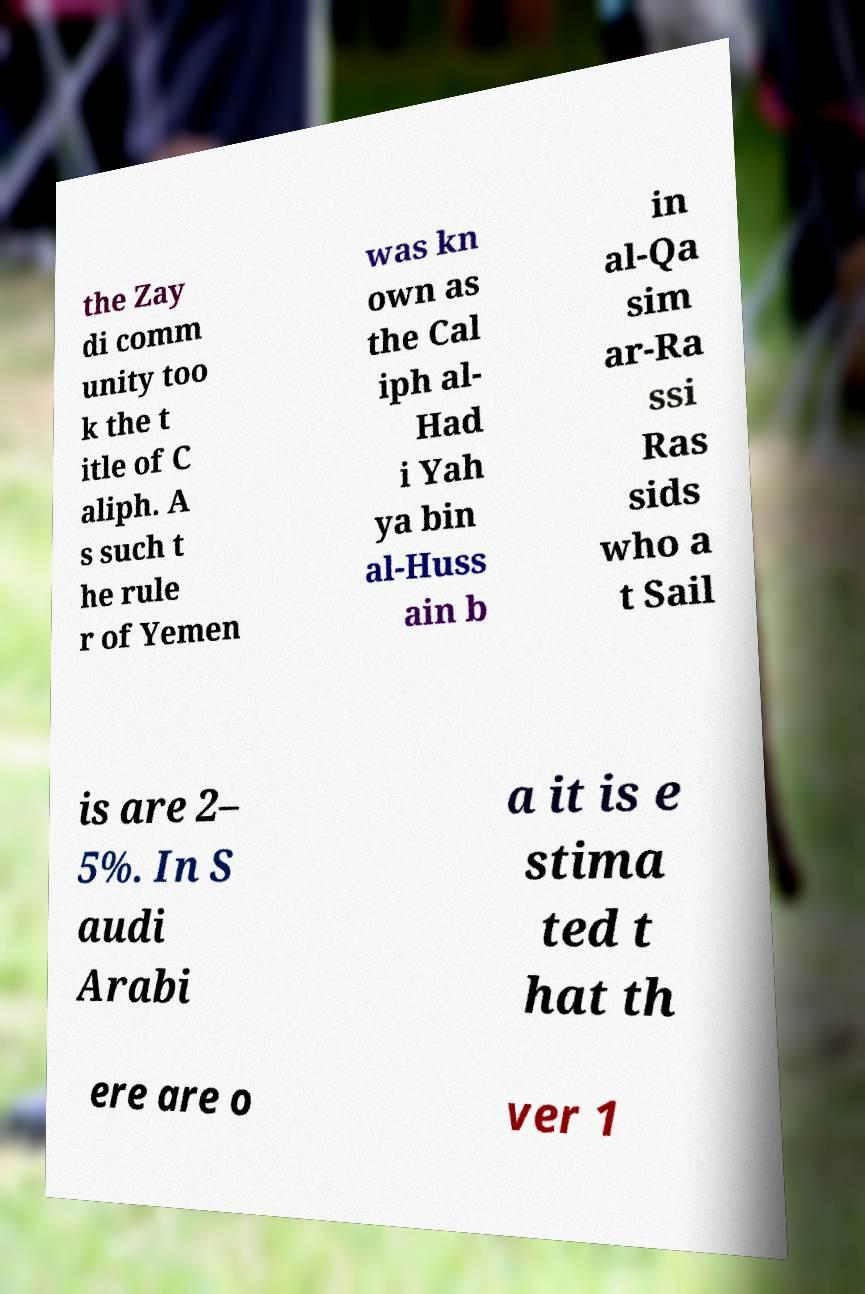Could you assist in decoding the text presented in this image and type it out clearly? the Zay di comm unity too k the t itle of C aliph. A s such t he rule r of Yemen was kn own as the Cal iph al- Had i Yah ya bin al-Huss ain b in al-Qa sim ar-Ra ssi Ras sids who a t Sail is are 2– 5%. In S audi Arabi a it is e stima ted t hat th ere are o ver 1 